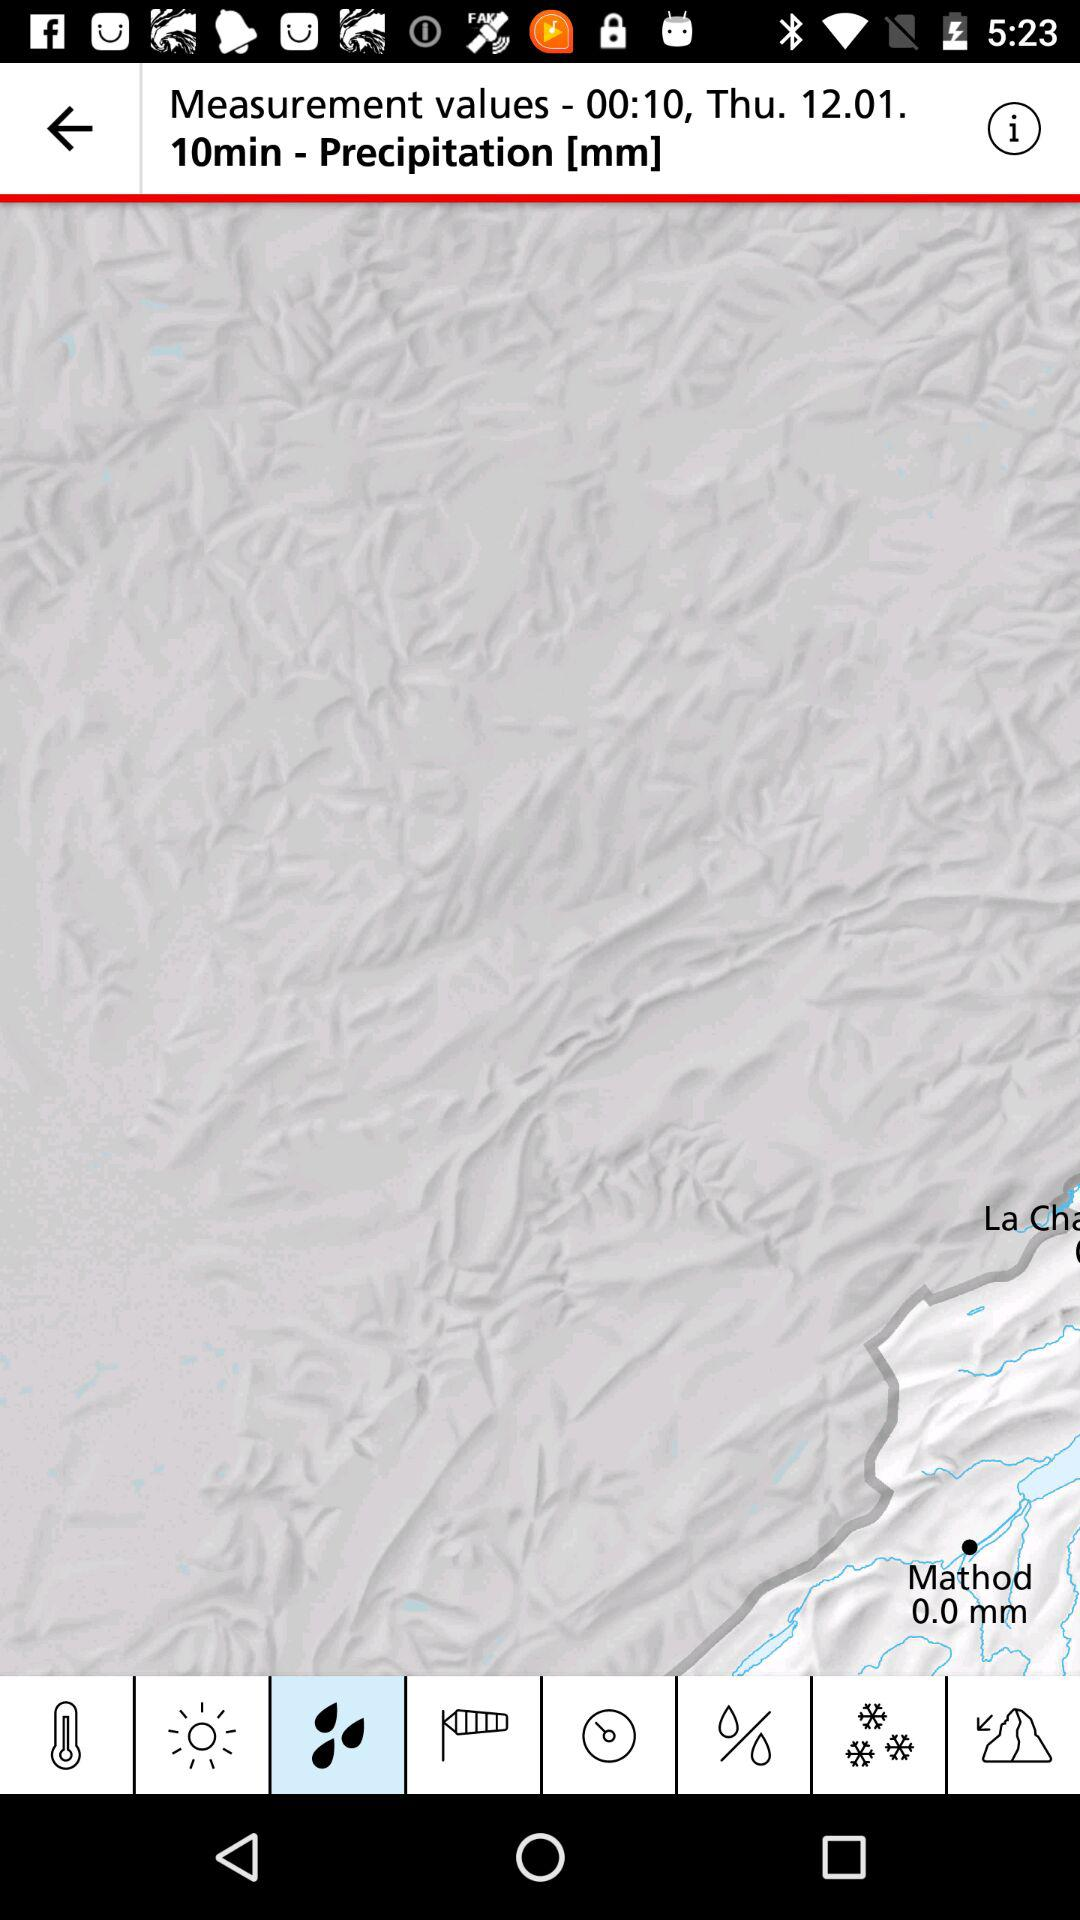What is the location?
When the provided information is insufficient, respond with <no answer>. <no answer> 